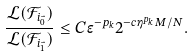Convert formula to latex. <formula><loc_0><loc_0><loc_500><loc_500>\frac { \mathcal { L } ( \mathcal { F } _ { i _ { \vec { 0 } } } ) } { \mathcal { L } ( \mathcal { F } _ { i _ { \vec { 1 } } } ) } \leq C \epsilon ^ { - p _ { k } } 2 ^ { - c \eta ^ { p _ { k } } M / N } .</formula> 